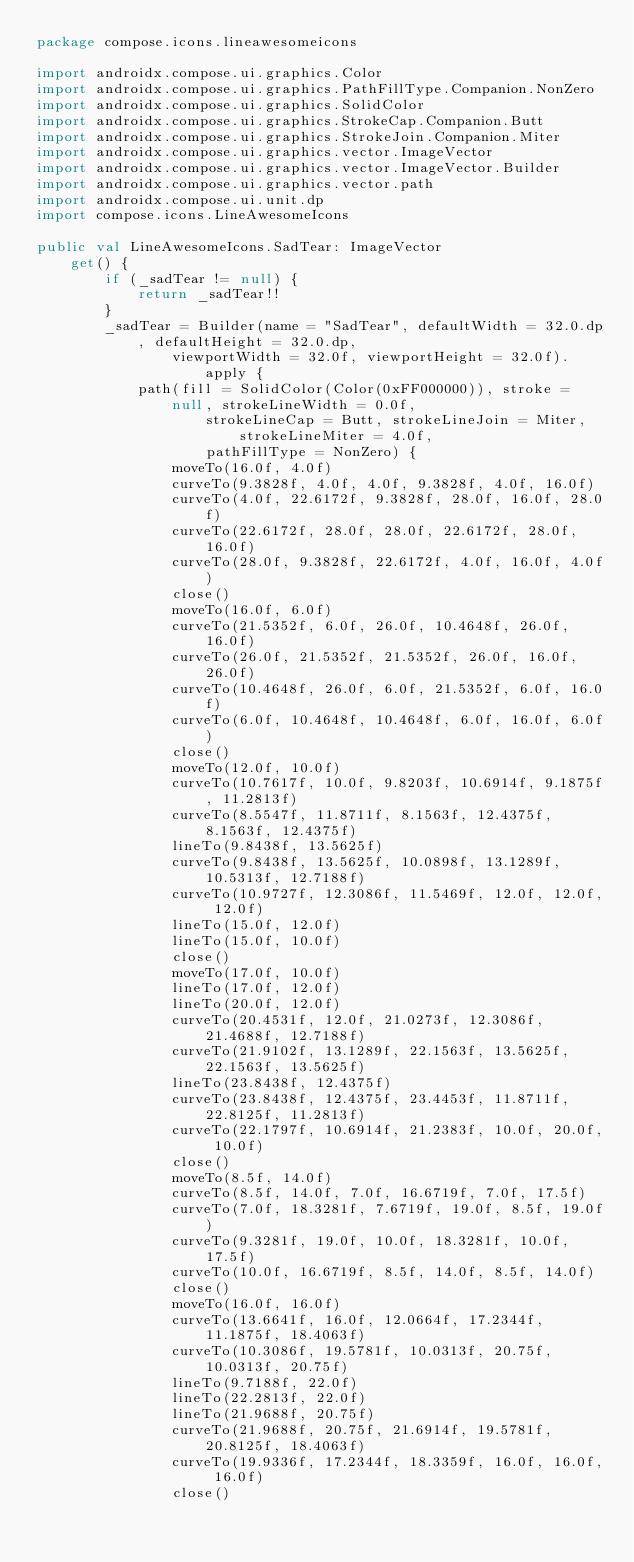<code> <loc_0><loc_0><loc_500><loc_500><_Kotlin_>package compose.icons.lineawesomeicons

import androidx.compose.ui.graphics.Color
import androidx.compose.ui.graphics.PathFillType.Companion.NonZero
import androidx.compose.ui.graphics.SolidColor
import androidx.compose.ui.graphics.StrokeCap.Companion.Butt
import androidx.compose.ui.graphics.StrokeJoin.Companion.Miter
import androidx.compose.ui.graphics.vector.ImageVector
import androidx.compose.ui.graphics.vector.ImageVector.Builder
import androidx.compose.ui.graphics.vector.path
import androidx.compose.ui.unit.dp
import compose.icons.LineAwesomeIcons

public val LineAwesomeIcons.SadTear: ImageVector
    get() {
        if (_sadTear != null) {
            return _sadTear!!
        }
        _sadTear = Builder(name = "SadTear", defaultWidth = 32.0.dp, defaultHeight = 32.0.dp,
                viewportWidth = 32.0f, viewportHeight = 32.0f).apply {
            path(fill = SolidColor(Color(0xFF000000)), stroke = null, strokeLineWidth = 0.0f,
                    strokeLineCap = Butt, strokeLineJoin = Miter, strokeLineMiter = 4.0f,
                    pathFillType = NonZero) {
                moveTo(16.0f, 4.0f)
                curveTo(9.3828f, 4.0f, 4.0f, 9.3828f, 4.0f, 16.0f)
                curveTo(4.0f, 22.6172f, 9.3828f, 28.0f, 16.0f, 28.0f)
                curveTo(22.6172f, 28.0f, 28.0f, 22.6172f, 28.0f, 16.0f)
                curveTo(28.0f, 9.3828f, 22.6172f, 4.0f, 16.0f, 4.0f)
                close()
                moveTo(16.0f, 6.0f)
                curveTo(21.5352f, 6.0f, 26.0f, 10.4648f, 26.0f, 16.0f)
                curveTo(26.0f, 21.5352f, 21.5352f, 26.0f, 16.0f, 26.0f)
                curveTo(10.4648f, 26.0f, 6.0f, 21.5352f, 6.0f, 16.0f)
                curveTo(6.0f, 10.4648f, 10.4648f, 6.0f, 16.0f, 6.0f)
                close()
                moveTo(12.0f, 10.0f)
                curveTo(10.7617f, 10.0f, 9.8203f, 10.6914f, 9.1875f, 11.2813f)
                curveTo(8.5547f, 11.8711f, 8.1563f, 12.4375f, 8.1563f, 12.4375f)
                lineTo(9.8438f, 13.5625f)
                curveTo(9.8438f, 13.5625f, 10.0898f, 13.1289f, 10.5313f, 12.7188f)
                curveTo(10.9727f, 12.3086f, 11.5469f, 12.0f, 12.0f, 12.0f)
                lineTo(15.0f, 12.0f)
                lineTo(15.0f, 10.0f)
                close()
                moveTo(17.0f, 10.0f)
                lineTo(17.0f, 12.0f)
                lineTo(20.0f, 12.0f)
                curveTo(20.4531f, 12.0f, 21.0273f, 12.3086f, 21.4688f, 12.7188f)
                curveTo(21.9102f, 13.1289f, 22.1563f, 13.5625f, 22.1563f, 13.5625f)
                lineTo(23.8438f, 12.4375f)
                curveTo(23.8438f, 12.4375f, 23.4453f, 11.8711f, 22.8125f, 11.2813f)
                curveTo(22.1797f, 10.6914f, 21.2383f, 10.0f, 20.0f, 10.0f)
                close()
                moveTo(8.5f, 14.0f)
                curveTo(8.5f, 14.0f, 7.0f, 16.6719f, 7.0f, 17.5f)
                curveTo(7.0f, 18.3281f, 7.6719f, 19.0f, 8.5f, 19.0f)
                curveTo(9.3281f, 19.0f, 10.0f, 18.3281f, 10.0f, 17.5f)
                curveTo(10.0f, 16.6719f, 8.5f, 14.0f, 8.5f, 14.0f)
                close()
                moveTo(16.0f, 16.0f)
                curveTo(13.6641f, 16.0f, 12.0664f, 17.2344f, 11.1875f, 18.4063f)
                curveTo(10.3086f, 19.5781f, 10.0313f, 20.75f, 10.0313f, 20.75f)
                lineTo(9.7188f, 22.0f)
                lineTo(22.2813f, 22.0f)
                lineTo(21.9688f, 20.75f)
                curveTo(21.9688f, 20.75f, 21.6914f, 19.5781f, 20.8125f, 18.4063f)
                curveTo(19.9336f, 17.2344f, 18.3359f, 16.0f, 16.0f, 16.0f)
                close()</code> 